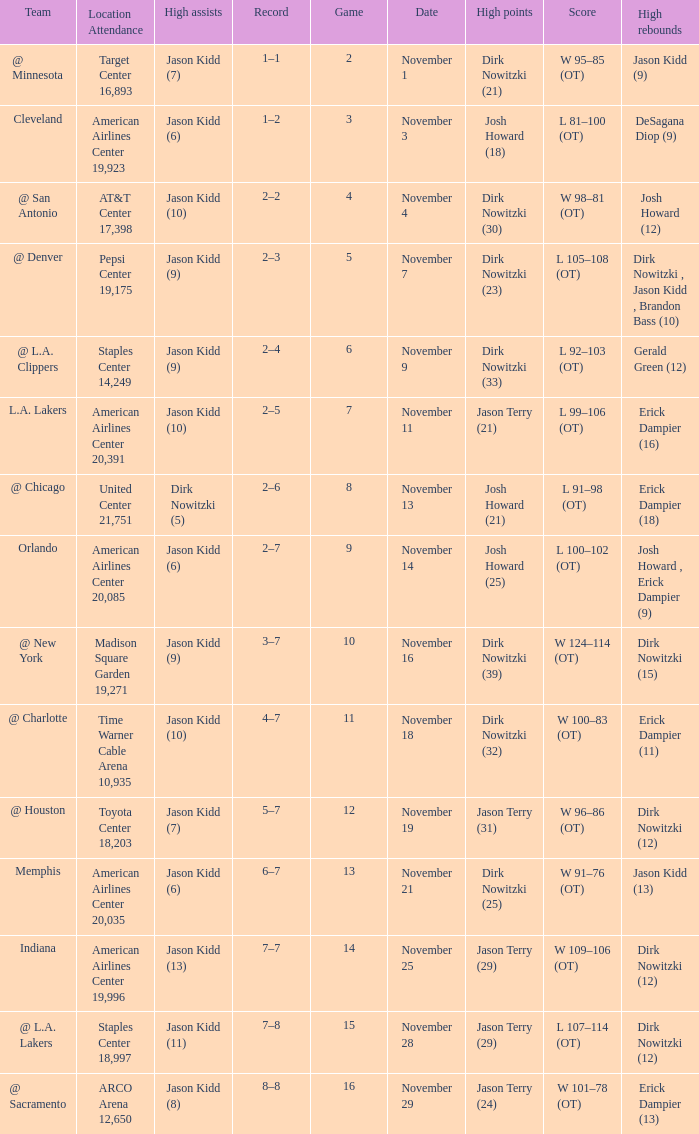What is the lowest Game, when Date is "November 1"? 2.0. 